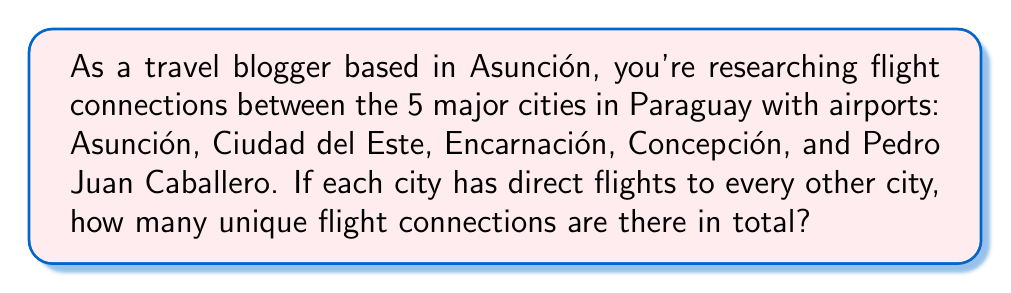Show me your answer to this math problem. Let's approach this step-by-step:

1) This is a combination problem. We need to find the number of ways to choose 2 cities from 5 cities, as each flight connection is between 2 cities.

2) The formula for combinations is:

   $$C(n,r) = \frac{n!}{r!(n-r)!}$$

   Where $n$ is the total number of items (cities in this case) and $r$ is the number of items being chosen.

3) In this problem, $n = 5$ (total cities) and $r = 2$ (cities per connection).

4) Plugging these values into the formula:

   $$C(5,2) = \frac{5!}{2!(5-2)!} = \frac{5!}{2!(3)!}$$

5) Expanding this:

   $$\frac{5 \cdot 4 \cdot 3!}{2 \cdot 1 \cdot 3!}$$

6) The 3! cancels out in the numerator and denominator:

   $$\frac{5 \cdot 4}{2 \cdot 1} = \frac{20}{2} = 10$$

Therefore, there are 10 unique flight connections between the 5 major cities.
Answer: 10 connections 